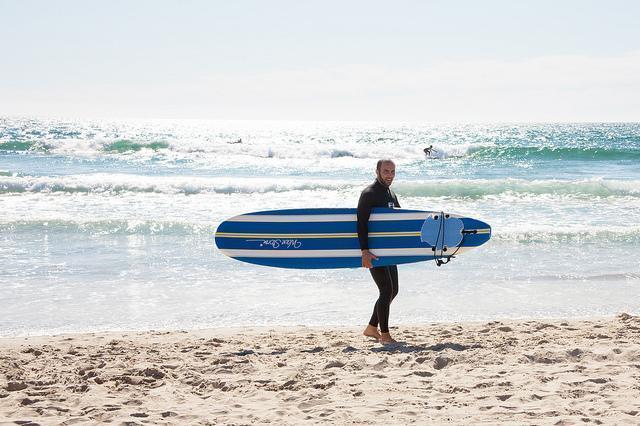What type of outfit is the man wearing?
Indicate the correct response by choosing from the four available options to answer the question.
Options: Sweat suit, track suit, scuba suit, wet suit. Wet suit. 